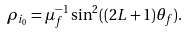<formula> <loc_0><loc_0><loc_500><loc_500>\rho _ { i _ { 0 } } = \mu _ { f } ^ { - 1 } \sin ^ { 2 } ( ( 2 L + 1 ) \theta _ { f } ) .</formula> 